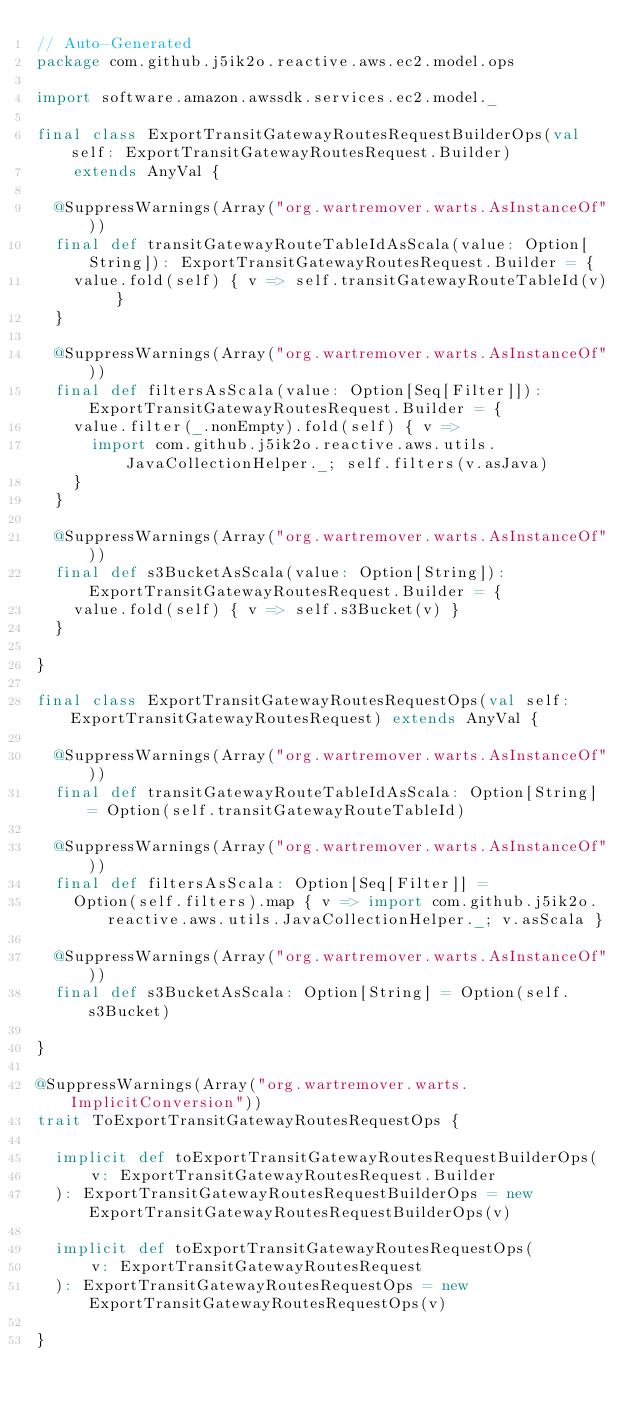<code> <loc_0><loc_0><loc_500><loc_500><_Scala_>// Auto-Generated
package com.github.j5ik2o.reactive.aws.ec2.model.ops

import software.amazon.awssdk.services.ec2.model._

final class ExportTransitGatewayRoutesRequestBuilderOps(val self: ExportTransitGatewayRoutesRequest.Builder)
    extends AnyVal {

  @SuppressWarnings(Array("org.wartremover.warts.AsInstanceOf"))
  final def transitGatewayRouteTableIdAsScala(value: Option[String]): ExportTransitGatewayRoutesRequest.Builder = {
    value.fold(self) { v => self.transitGatewayRouteTableId(v) }
  }

  @SuppressWarnings(Array("org.wartremover.warts.AsInstanceOf"))
  final def filtersAsScala(value: Option[Seq[Filter]]): ExportTransitGatewayRoutesRequest.Builder = {
    value.filter(_.nonEmpty).fold(self) { v =>
      import com.github.j5ik2o.reactive.aws.utils.JavaCollectionHelper._; self.filters(v.asJava)
    }
  }

  @SuppressWarnings(Array("org.wartremover.warts.AsInstanceOf"))
  final def s3BucketAsScala(value: Option[String]): ExportTransitGatewayRoutesRequest.Builder = {
    value.fold(self) { v => self.s3Bucket(v) }
  }

}

final class ExportTransitGatewayRoutesRequestOps(val self: ExportTransitGatewayRoutesRequest) extends AnyVal {

  @SuppressWarnings(Array("org.wartremover.warts.AsInstanceOf"))
  final def transitGatewayRouteTableIdAsScala: Option[String] = Option(self.transitGatewayRouteTableId)

  @SuppressWarnings(Array("org.wartremover.warts.AsInstanceOf"))
  final def filtersAsScala: Option[Seq[Filter]] =
    Option(self.filters).map { v => import com.github.j5ik2o.reactive.aws.utils.JavaCollectionHelper._; v.asScala }

  @SuppressWarnings(Array("org.wartremover.warts.AsInstanceOf"))
  final def s3BucketAsScala: Option[String] = Option(self.s3Bucket)

}

@SuppressWarnings(Array("org.wartremover.warts.ImplicitConversion"))
trait ToExportTransitGatewayRoutesRequestOps {

  implicit def toExportTransitGatewayRoutesRequestBuilderOps(
      v: ExportTransitGatewayRoutesRequest.Builder
  ): ExportTransitGatewayRoutesRequestBuilderOps = new ExportTransitGatewayRoutesRequestBuilderOps(v)

  implicit def toExportTransitGatewayRoutesRequestOps(
      v: ExportTransitGatewayRoutesRequest
  ): ExportTransitGatewayRoutesRequestOps = new ExportTransitGatewayRoutesRequestOps(v)

}
</code> 